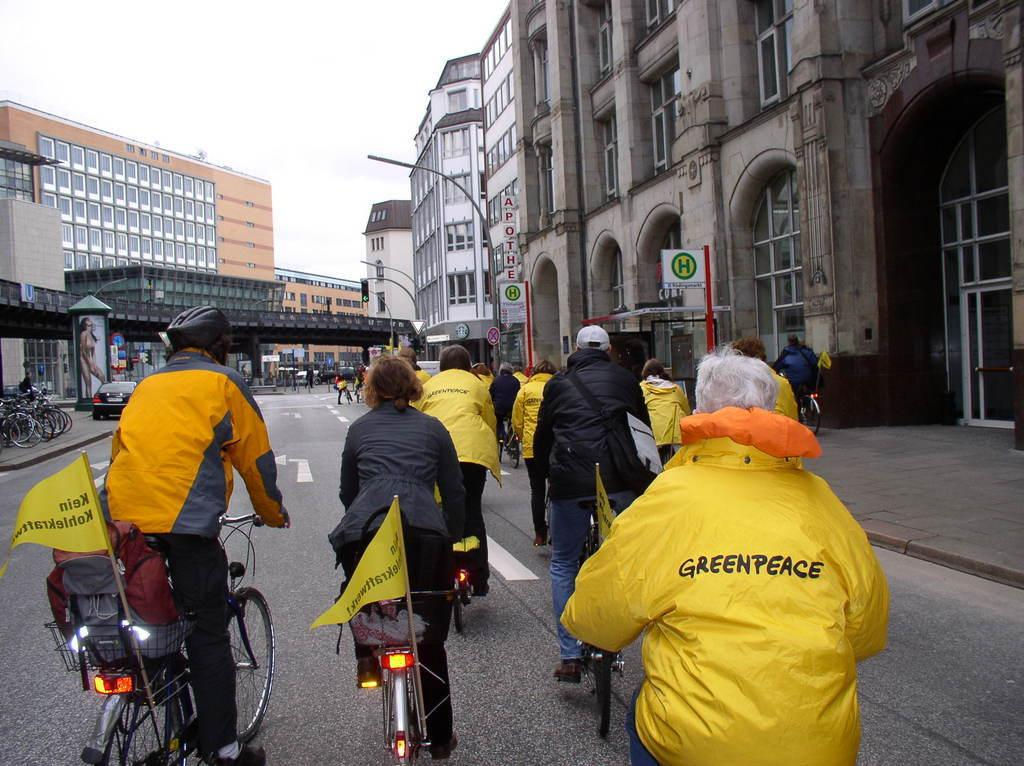What are the people in the image doing? The people in the image are riding bicycles. What can be seen on the bicycles? The bicycles have flags on them. What type of structures are visible in the image? There are buildings visible in the image. What is located on the left side of the image? There is a car on the left side of the image. How many parts of the gun can be seen in the image? There is no gun present in the image. What are the boys doing in the image? The provided facts do not mention any boys in the image; it only mentions a group of people. 